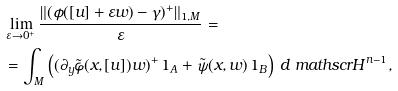Convert formula to latex. <formula><loc_0><loc_0><loc_500><loc_500>& \lim _ { \varepsilon \to 0 ^ { + } } \frac { \| ( \phi ( [ u ] + \varepsilon w ) - \gamma ) ^ { + } \| _ { 1 , M } } { \varepsilon } = \\ & = \int _ { M } \left ( ( \partial _ { y } \tilde { \varphi } ( x , [ u ] ) w ) ^ { + } \, 1 _ { A } + \tilde { \psi } ( x , w ) \, 1 _ { B } \right ) \, d \ m a t h s c r { H } ^ { n - 1 } ,</formula> 